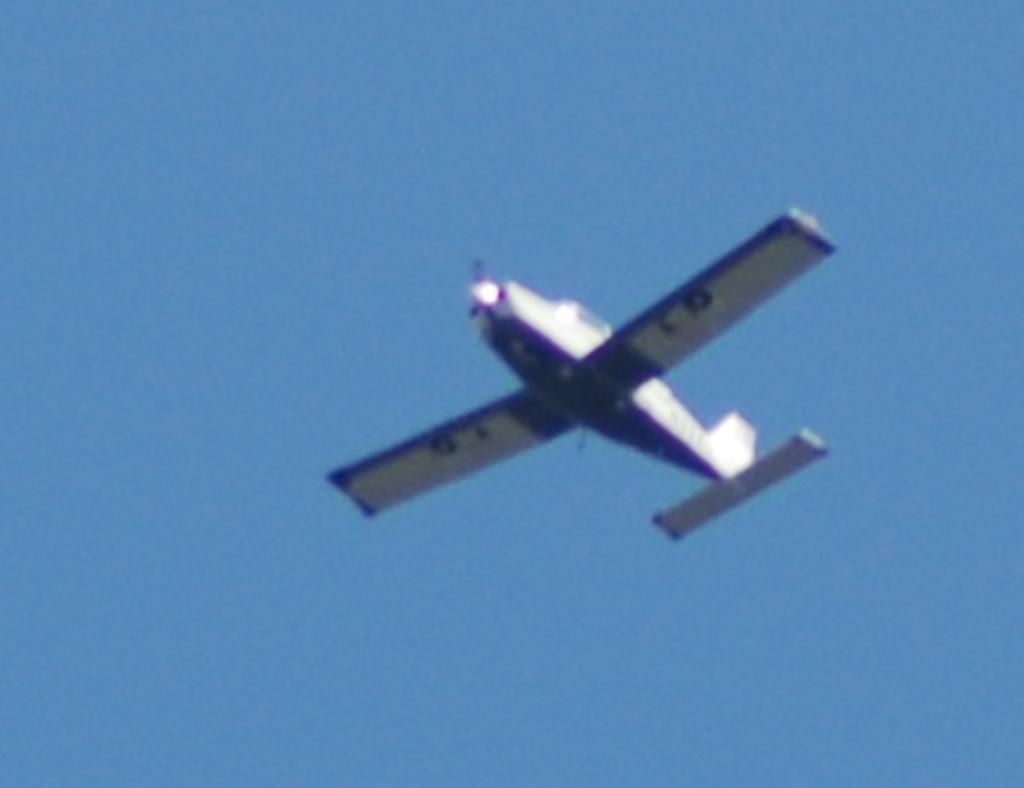What is the main subject of the picture? The main subject of the picture is a jet plane. What is the color of the sky in the picture? The sky is blue in the picture. What type of space apparatus can be seen in the image? There is no space apparatus present in the image; it features a jet plane in the sky. Is there any snow visible in the image? There is no snow present in the image; the sky is blue, which typically indicates clear weather. 